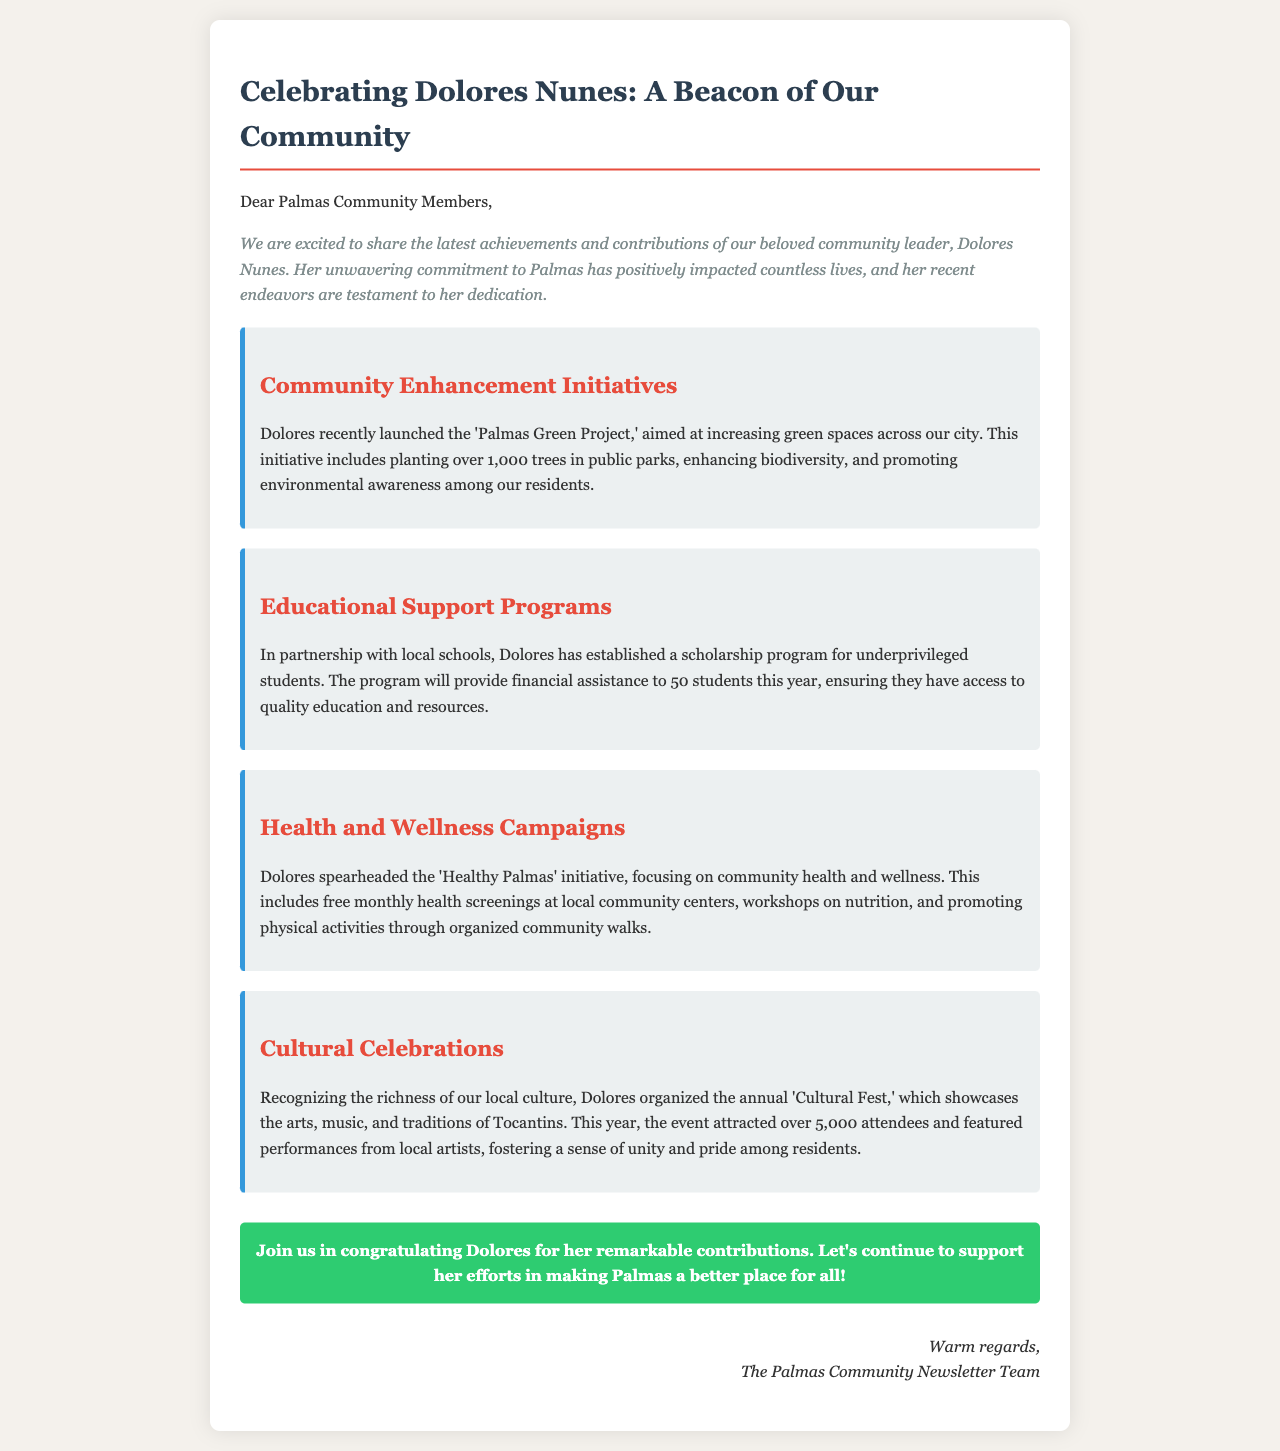What is the title of the newsletter? The title of the newsletter, as stated in the document, is "Celebrating Dolores Nunes: A Beacon of Our Community."
Answer: Celebrating Dolores Nunes: A Beacon of Our Community How many trees are being planted in the 'Palmas Green Project'? The document mentions that over 1,000 trees are being planted in the project.
Answer: 1,000 trees What is the name of the scholarship program established by Dolores? The scholarship program is referred to as the "scholarship program for underprivileged students."
Answer: scholarship program for underprivileged students How many students will receive financial assistance from the scholarship program this year? The document states that the program will provide financial assistance to 50 students this year.
Answer: 50 students What community initiative focuses on health and wellness? The initiative that focuses on health and wellness is called "Healthy Palmas."
Answer: Healthy Palmas Which event attracted over 5,000 attendees this year? The annual event that attracted over 5,000 attendees is the "Cultural Fest."
Answer: Cultural Fest What is the primary goal of the 'Palmas Green Project'? The primary goal of the project is to increase green spaces across the city.
Answer: increase green spaces What does the 'Healthy Palmas' initiative include? It includes free monthly health screenings, workshops on nutrition, and community walks.
Answer: health screenings, workshops, community walks What role does Dolores play in the Palmas community? Dolores is described as a beloved community leader.
Answer: community leader 